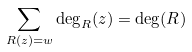<formula> <loc_0><loc_0><loc_500><loc_500>\sum _ { R ( z ) = w } \deg _ { R } ( z ) = \deg ( R )</formula> 